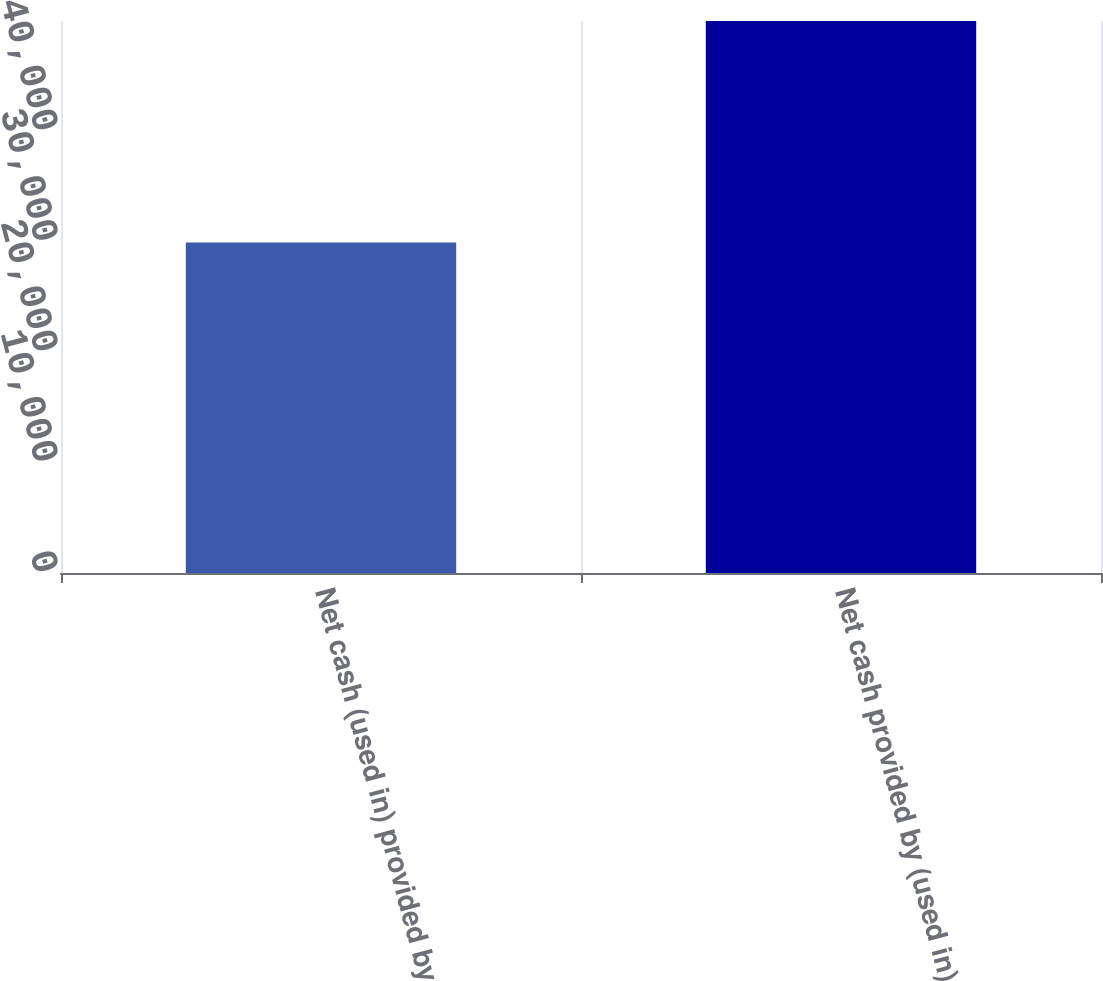Convert chart to OTSL. <chart><loc_0><loc_0><loc_500><loc_500><bar_chart><fcel>Net cash (used in) provided by<fcel>Net cash provided by (used in)<nl><fcel>29934<fcel>49990<nl></chart> 